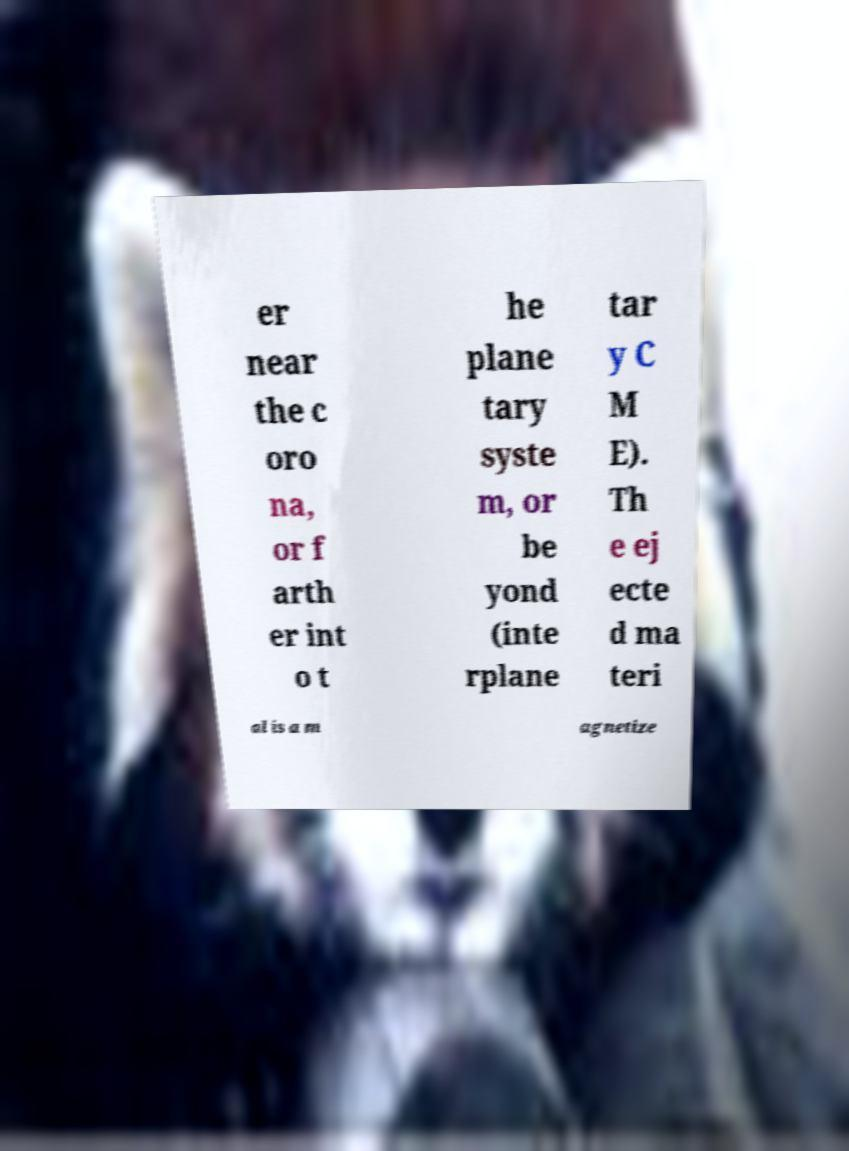I need the written content from this picture converted into text. Can you do that? er near the c oro na, or f arth er int o t he plane tary syste m, or be yond (inte rplane tar y C M E). Th e ej ecte d ma teri al is a m agnetize 